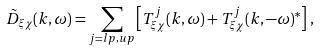Convert formula to latex. <formula><loc_0><loc_0><loc_500><loc_500>\tilde { D } _ { \xi \chi } ( { k } , \omega ) = \sum _ { j = l p , u p } \left [ T ^ { j } _ { \xi \chi } ( { k } , \omega ) + T ^ { j } _ { \xi \chi } ( { k } , - \omega ) ^ { * } \right ] \, ,</formula> 